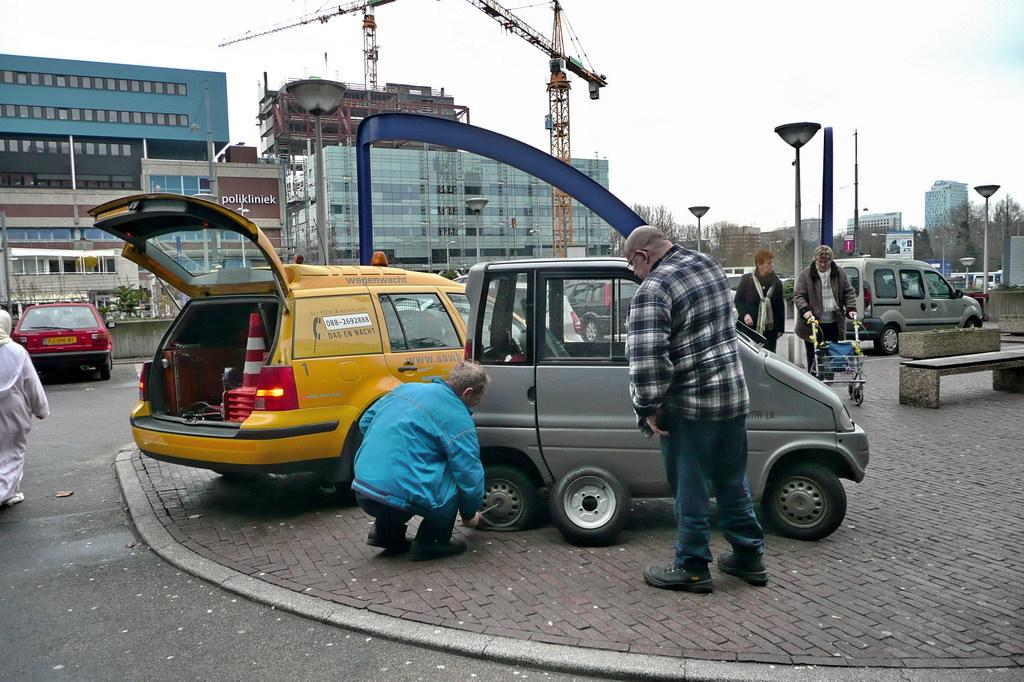<image>
Present a compact description of the photo's key features. A yellow car that says Dag En Nacht seems to be helping another motorist. 